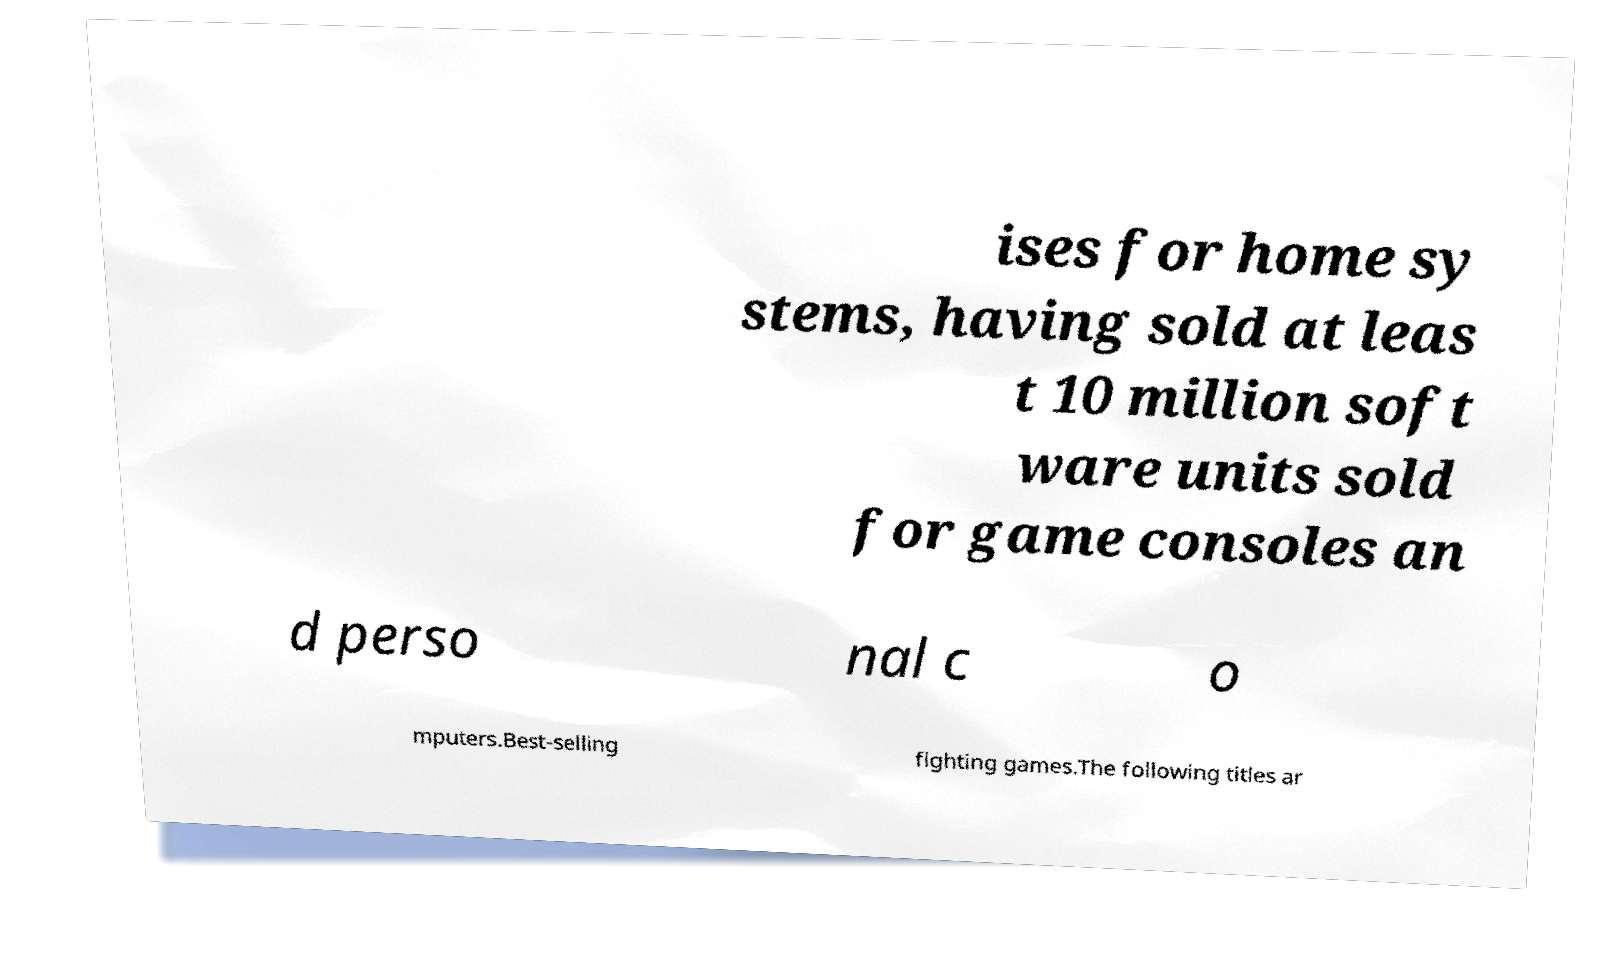I need the written content from this picture converted into text. Can you do that? ises for home sy stems, having sold at leas t 10 million soft ware units sold for game consoles an d perso nal c o mputers.Best-selling fighting games.The following titles ar 